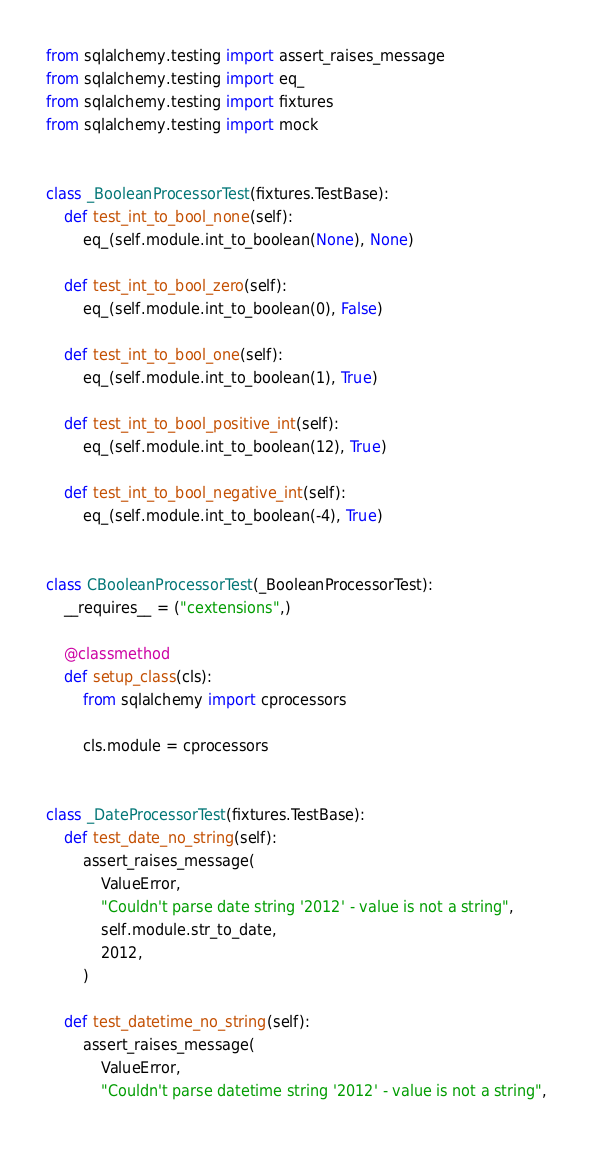Convert code to text. <code><loc_0><loc_0><loc_500><loc_500><_Python_>from sqlalchemy.testing import assert_raises_message
from sqlalchemy.testing import eq_
from sqlalchemy.testing import fixtures
from sqlalchemy.testing import mock


class _BooleanProcessorTest(fixtures.TestBase):
    def test_int_to_bool_none(self):
        eq_(self.module.int_to_boolean(None), None)

    def test_int_to_bool_zero(self):
        eq_(self.module.int_to_boolean(0), False)

    def test_int_to_bool_one(self):
        eq_(self.module.int_to_boolean(1), True)

    def test_int_to_bool_positive_int(self):
        eq_(self.module.int_to_boolean(12), True)

    def test_int_to_bool_negative_int(self):
        eq_(self.module.int_to_boolean(-4), True)


class CBooleanProcessorTest(_BooleanProcessorTest):
    __requires__ = ("cextensions",)

    @classmethod
    def setup_class(cls):
        from sqlalchemy import cprocessors

        cls.module = cprocessors


class _DateProcessorTest(fixtures.TestBase):
    def test_date_no_string(self):
        assert_raises_message(
            ValueError,
            "Couldn't parse date string '2012' - value is not a string",
            self.module.str_to_date,
            2012,
        )

    def test_datetime_no_string(self):
        assert_raises_message(
            ValueError,
            "Couldn't parse datetime string '2012' - value is not a string",</code> 